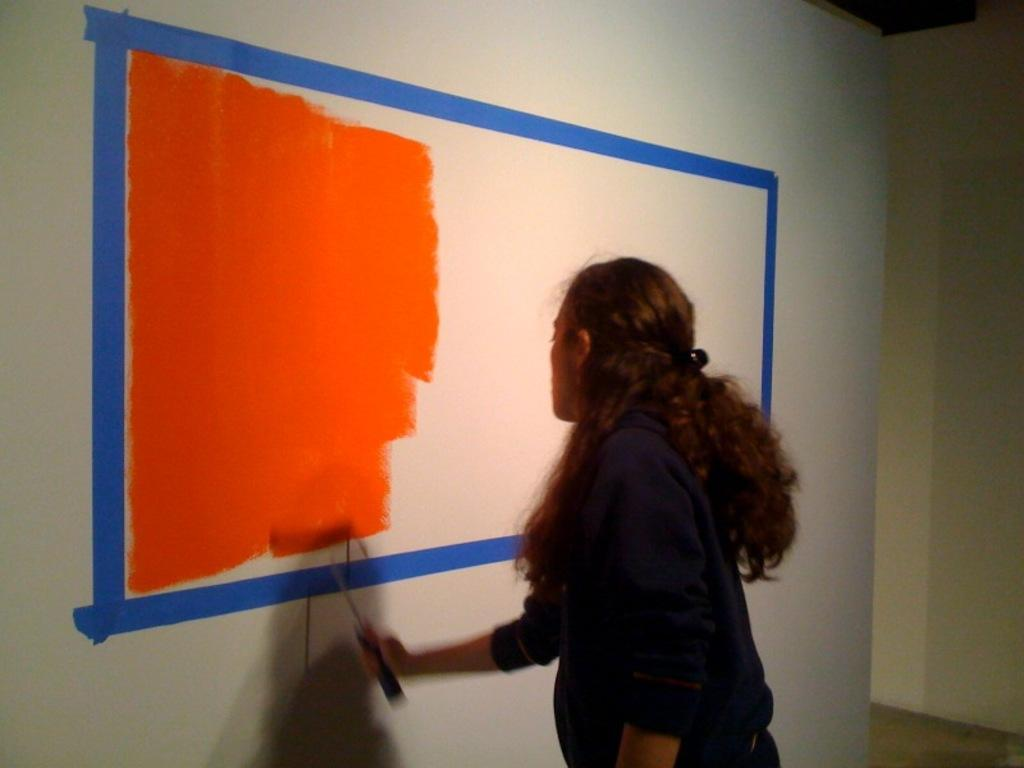Who is the person in the image? There is a woman in the image. What is the woman doing in the image? The woman is painting on a wall. Can you describe the painting on the wall? The painting on the wall has orange and blue colors. What type of tiger can be seen in the painting on the wall? There is no tiger present in the image or the painting on the wall. 